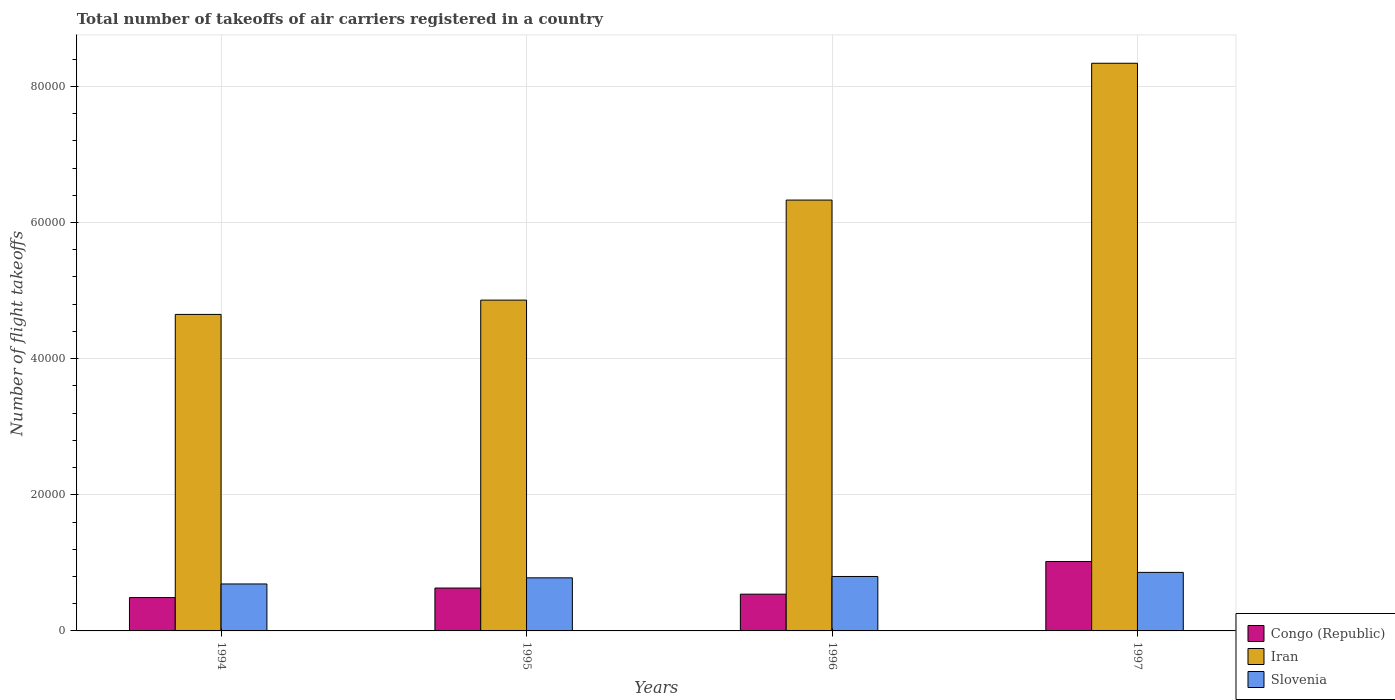How many different coloured bars are there?
Your response must be concise. 3. How many groups of bars are there?
Provide a short and direct response. 4. Are the number of bars per tick equal to the number of legend labels?
Make the answer very short. Yes. How many bars are there on the 1st tick from the left?
Offer a terse response. 3. In how many cases, is the number of bars for a given year not equal to the number of legend labels?
Your answer should be very brief. 0. What is the total number of flight takeoffs in Congo (Republic) in 1996?
Provide a succinct answer. 5400. Across all years, what is the maximum total number of flight takeoffs in Congo (Republic)?
Keep it short and to the point. 1.02e+04. Across all years, what is the minimum total number of flight takeoffs in Congo (Republic)?
Give a very brief answer. 4900. In which year was the total number of flight takeoffs in Congo (Republic) maximum?
Your response must be concise. 1997. What is the total total number of flight takeoffs in Slovenia in the graph?
Keep it short and to the point. 3.13e+04. What is the difference between the total number of flight takeoffs in Slovenia in 1996 and that in 1997?
Your answer should be compact. -600. What is the difference between the total number of flight takeoffs in Iran in 1996 and the total number of flight takeoffs in Slovenia in 1994?
Your response must be concise. 5.64e+04. What is the average total number of flight takeoffs in Iran per year?
Make the answer very short. 6.04e+04. In the year 1994, what is the difference between the total number of flight takeoffs in Slovenia and total number of flight takeoffs in Congo (Republic)?
Offer a terse response. 2000. What is the ratio of the total number of flight takeoffs in Slovenia in 1995 to that in 1996?
Make the answer very short. 0.97. Is the difference between the total number of flight takeoffs in Slovenia in 1994 and 1995 greater than the difference between the total number of flight takeoffs in Congo (Republic) in 1994 and 1995?
Make the answer very short. Yes. What is the difference between the highest and the second highest total number of flight takeoffs in Slovenia?
Make the answer very short. 600. What is the difference between the highest and the lowest total number of flight takeoffs in Congo (Republic)?
Your response must be concise. 5300. What does the 3rd bar from the left in 1996 represents?
Keep it short and to the point. Slovenia. What does the 3rd bar from the right in 1994 represents?
Make the answer very short. Congo (Republic). Is it the case that in every year, the sum of the total number of flight takeoffs in Congo (Republic) and total number of flight takeoffs in Iran is greater than the total number of flight takeoffs in Slovenia?
Your answer should be compact. Yes. How many bars are there?
Offer a very short reply. 12. How many years are there in the graph?
Offer a terse response. 4. Are the values on the major ticks of Y-axis written in scientific E-notation?
Offer a terse response. No. Does the graph contain any zero values?
Give a very brief answer. No. Where does the legend appear in the graph?
Your answer should be compact. Bottom right. How are the legend labels stacked?
Give a very brief answer. Vertical. What is the title of the graph?
Make the answer very short. Total number of takeoffs of air carriers registered in a country. Does "High income: OECD" appear as one of the legend labels in the graph?
Ensure brevity in your answer.  No. What is the label or title of the X-axis?
Your answer should be compact. Years. What is the label or title of the Y-axis?
Your response must be concise. Number of flight takeoffs. What is the Number of flight takeoffs in Congo (Republic) in 1994?
Provide a short and direct response. 4900. What is the Number of flight takeoffs of Iran in 1994?
Offer a terse response. 4.65e+04. What is the Number of flight takeoffs of Slovenia in 1994?
Provide a succinct answer. 6900. What is the Number of flight takeoffs in Congo (Republic) in 1995?
Give a very brief answer. 6300. What is the Number of flight takeoffs of Iran in 1995?
Provide a succinct answer. 4.86e+04. What is the Number of flight takeoffs in Slovenia in 1995?
Keep it short and to the point. 7800. What is the Number of flight takeoffs of Congo (Republic) in 1996?
Your response must be concise. 5400. What is the Number of flight takeoffs of Iran in 1996?
Your answer should be compact. 6.33e+04. What is the Number of flight takeoffs of Slovenia in 1996?
Keep it short and to the point. 8000. What is the Number of flight takeoffs in Congo (Republic) in 1997?
Offer a terse response. 1.02e+04. What is the Number of flight takeoffs of Iran in 1997?
Offer a terse response. 8.34e+04. What is the Number of flight takeoffs of Slovenia in 1997?
Your answer should be compact. 8600. Across all years, what is the maximum Number of flight takeoffs in Congo (Republic)?
Make the answer very short. 1.02e+04. Across all years, what is the maximum Number of flight takeoffs of Iran?
Your answer should be very brief. 8.34e+04. Across all years, what is the maximum Number of flight takeoffs in Slovenia?
Your answer should be compact. 8600. Across all years, what is the minimum Number of flight takeoffs in Congo (Republic)?
Provide a short and direct response. 4900. Across all years, what is the minimum Number of flight takeoffs of Iran?
Provide a succinct answer. 4.65e+04. Across all years, what is the minimum Number of flight takeoffs of Slovenia?
Your response must be concise. 6900. What is the total Number of flight takeoffs of Congo (Republic) in the graph?
Your answer should be very brief. 2.68e+04. What is the total Number of flight takeoffs in Iran in the graph?
Provide a succinct answer. 2.42e+05. What is the total Number of flight takeoffs of Slovenia in the graph?
Make the answer very short. 3.13e+04. What is the difference between the Number of flight takeoffs in Congo (Republic) in 1994 and that in 1995?
Keep it short and to the point. -1400. What is the difference between the Number of flight takeoffs in Iran in 1994 and that in 1995?
Make the answer very short. -2100. What is the difference between the Number of flight takeoffs of Slovenia in 1994 and that in 1995?
Keep it short and to the point. -900. What is the difference between the Number of flight takeoffs in Congo (Republic) in 1994 and that in 1996?
Provide a succinct answer. -500. What is the difference between the Number of flight takeoffs of Iran in 1994 and that in 1996?
Your answer should be compact. -1.68e+04. What is the difference between the Number of flight takeoffs in Slovenia in 1994 and that in 1996?
Your response must be concise. -1100. What is the difference between the Number of flight takeoffs of Congo (Republic) in 1994 and that in 1997?
Ensure brevity in your answer.  -5300. What is the difference between the Number of flight takeoffs in Iran in 1994 and that in 1997?
Give a very brief answer. -3.69e+04. What is the difference between the Number of flight takeoffs of Slovenia in 1994 and that in 1997?
Provide a succinct answer. -1700. What is the difference between the Number of flight takeoffs of Congo (Republic) in 1995 and that in 1996?
Provide a succinct answer. 900. What is the difference between the Number of flight takeoffs in Iran in 1995 and that in 1996?
Your response must be concise. -1.47e+04. What is the difference between the Number of flight takeoffs of Slovenia in 1995 and that in 1996?
Offer a terse response. -200. What is the difference between the Number of flight takeoffs of Congo (Republic) in 1995 and that in 1997?
Give a very brief answer. -3900. What is the difference between the Number of flight takeoffs of Iran in 1995 and that in 1997?
Keep it short and to the point. -3.48e+04. What is the difference between the Number of flight takeoffs of Slovenia in 1995 and that in 1997?
Give a very brief answer. -800. What is the difference between the Number of flight takeoffs of Congo (Republic) in 1996 and that in 1997?
Your answer should be compact. -4800. What is the difference between the Number of flight takeoffs in Iran in 1996 and that in 1997?
Provide a succinct answer. -2.01e+04. What is the difference between the Number of flight takeoffs in Slovenia in 1996 and that in 1997?
Your response must be concise. -600. What is the difference between the Number of flight takeoffs of Congo (Republic) in 1994 and the Number of flight takeoffs of Iran in 1995?
Make the answer very short. -4.37e+04. What is the difference between the Number of flight takeoffs of Congo (Republic) in 1994 and the Number of flight takeoffs of Slovenia in 1995?
Give a very brief answer. -2900. What is the difference between the Number of flight takeoffs in Iran in 1994 and the Number of flight takeoffs in Slovenia in 1995?
Offer a very short reply. 3.87e+04. What is the difference between the Number of flight takeoffs in Congo (Republic) in 1994 and the Number of flight takeoffs in Iran in 1996?
Make the answer very short. -5.84e+04. What is the difference between the Number of flight takeoffs of Congo (Republic) in 1994 and the Number of flight takeoffs of Slovenia in 1996?
Offer a terse response. -3100. What is the difference between the Number of flight takeoffs in Iran in 1994 and the Number of flight takeoffs in Slovenia in 1996?
Give a very brief answer. 3.85e+04. What is the difference between the Number of flight takeoffs in Congo (Republic) in 1994 and the Number of flight takeoffs in Iran in 1997?
Your answer should be compact. -7.85e+04. What is the difference between the Number of flight takeoffs of Congo (Republic) in 1994 and the Number of flight takeoffs of Slovenia in 1997?
Keep it short and to the point. -3700. What is the difference between the Number of flight takeoffs of Iran in 1994 and the Number of flight takeoffs of Slovenia in 1997?
Your answer should be compact. 3.79e+04. What is the difference between the Number of flight takeoffs of Congo (Republic) in 1995 and the Number of flight takeoffs of Iran in 1996?
Keep it short and to the point. -5.70e+04. What is the difference between the Number of flight takeoffs of Congo (Republic) in 1995 and the Number of flight takeoffs of Slovenia in 1996?
Offer a very short reply. -1700. What is the difference between the Number of flight takeoffs of Iran in 1995 and the Number of flight takeoffs of Slovenia in 1996?
Give a very brief answer. 4.06e+04. What is the difference between the Number of flight takeoffs in Congo (Republic) in 1995 and the Number of flight takeoffs in Iran in 1997?
Keep it short and to the point. -7.71e+04. What is the difference between the Number of flight takeoffs in Congo (Republic) in 1995 and the Number of flight takeoffs in Slovenia in 1997?
Ensure brevity in your answer.  -2300. What is the difference between the Number of flight takeoffs of Congo (Republic) in 1996 and the Number of flight takeoffs of Iran in 1997?
Make the answer very short. -7.80e+04. What is the difference between the Number of flight takeoffs of Congo (Republic) in 1996 and the Number of flight takeoffs of Slovenia in 1997?
Your response must be concise. -3200. What is the difference between the Number of flight takeoffs in Iran in 1996 and the Number of flight takeoffs in Slovenia in 1997?
Provide a succinct answer. 5.47e+04. What is the average Number of flight takeoffs of Congo (Republic) per year?
Ensure brevity in your answer.  6700. What is the average Number of flight takeoffs in Iran per year?
Your answer should be very brief. 6.04e+04. What is the average Number of flight takeoffs of Slovenia per year?
Provide a succinct answer. 7825. In the year 1994, what is the difference between the Number of flight takeoffs of Congo (Republic) and Number of flight takeoffs of Iran?
Provide a succinct answer. -4.16e+04. In the year 1994, what is the difference between the Number of flight takeoffs of Congo (Republic) and Number of flight takeoffs of Slovenia?
Give a very brief answer. -2000. In the year 1994, what is the difference between the Number of flight takeoffs of Iran and Number of flight takeoffs of Slovenia?
Your answer should be very brief. 3.96e+04. In the year 1995, what is the difference between the Number of flight takeoffs of Congo (Republic) and Number of flight takeoffs of Iran?
Make the answer very short. -4.23e+04. In the year 1995, what is the difference between the Number of flight takeoffs in Congo (Republic) and Number of flight takeoffs in Slovenia?
Your answer should be compact. -1500. In the year 1995, what is the difference between the Number of flight takeoffs of Iran and Number of flight takeoffs of Slovenia?
Offer a very short reply. 4.08e+04. In the year 1996, what is the difference between the Number of flight takeoffs of Congo (Republic) and Number of flight takeoffs of Iran?
Ensure brevity in your answer.  -5.79e+04. In the year 1996, what is the difference between the Number of flight takeoffs in Congo (Republic) and Number of flight takeoffs in Slovenia?
Your answer should be very brief. -2600. In the year 1996, what is the difference between the Number of flight takeoffs of Iran and Number of flight takeoffs of Slovenia?
Your response must be concise. 5.53e+04. In the year 1997, what is the difference between the Number of flight takeoffs of Congo (Republic) and Number of flight takeoffs of Iran?
Your response must be concise. -7.32e+04. In the year 1997, what is the difference between the Number of flight takeoffs of Congo (Republic) and Number of flight takeoffs of Slovenia?
Your answer should be very brief. 1600. In the year 1997, what is the difference between the Number of flight takeoffs of Iran and Number of flight takeoffs of Slovenia?
Keep it short and to the point. 7.48e+04. What is the ratio of the Number of flight takeoffs in Congo (Republic) in 1994 to that in 1995?
Offer a terse response. 0.78. What is the ratio of the Number of flight takeoffs in Iran in 1994 to that in 1995?
Keep it short and to the point. 0.96. What is the ratio of the Number of flight takeoffs of Slovenia in 1994 to that in 1995?
Your response must be concise. 0.88. What is the ratio of the Number of flight takeoffs in Congo (Republic) in 1994 to that in 1996?
Provide a short and direct response. 0.91. What is the ratio of the Number of flight takeoffs of Iran in 1994 to that in 1996?
Provide a succinct answer. 0.73. What is the ratio of the Number of flight takeoffs of Slovenia in 1994 to that in 1996?
Make the answer very short. 0.86. What is the ratio of the Number of flight takeoffs in Congo (Republic) in 1994 to that in 1997?
Provide a succinct answer. 0.48. What is the ratio of the Number of flight takeoffs of Iran in 1994 to that in 1997?
Offer a terse response. 0.56. What is the ratio of the Number of flight takeoffs in Slovenia in 1994 to that in 1997?
Your answer should be very brief. 0.8. What is the ratio of the Number of flight takeoffs in Iran in 1995 to that in 1996?
Provide a succinct answer. 0.77. What is the ratio of the Number of flight takeoffs in Slovenia in 1995 to that in 1996?
Offer a terse response. 0.97. What is the ratio of the Number of flight takeoffs of Congo (Republic) in 1995 to that in 1997?
Your response must be concise. 0.62. What is the ratio of the Number of flight takeoffs in Iran in 1995 to that in 1997?
Offer a very short reply. 0.58. What is the ratio of the Number of flight takeoffs in Slovenia in 1995 to that in 1997?
Offer a terse response. 0.91. What is the ratio of the Number of flight takeoffs of Congo (Republic) in 1996 to that in 1997?
Your answer should be very brief. 0.53. What is the ratio of the Number of flight takeoffs of Iran in 1996 to that in 1997?
Keep it short and to the point. 0.76. What is the ratio of the Number of flight takeoffs of Slovenia in 1996 to that in 1997?
Provide a succinct answer. 0.93. What is the difference between the highest and the second highest Number of flight takeoffs of Congo (Republic)?
Your response must be concise. 3900. What is the difference between the highest and the second highest Number of flight takeoffs of Iran?
Provide a succinct answer. 2.01e+04. What is the difference between the highest and the second highest Number of flight takeoffs of Slovenia?
Offer a terse response. 600. What is the difference between the highest and the lowest Number of flight takeoffs of Congo (Republic)?
Offer a terse response. 5300. What is the difference between the highest and the lowest Number of flight takeoffs in Iran?
Make the answer very short. 3.69e+04. What is the difference between the highest and the lowest Number of flight takeoffs in Slovenia?
Give a very brief answer. 1700. 